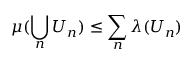<formula> <loc_0><loc_0><loc_500><loc_500>\mu ( \bigcup _ { n } U _ { n } ) \leq \sum _ { n } \lambda ( U _ { n } )</formula> 